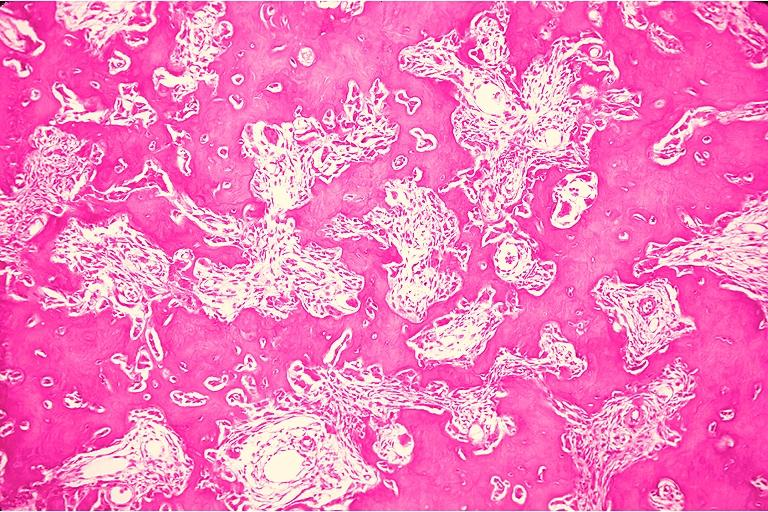s oral present?
Answer the question using a single word or phrase. Yes 